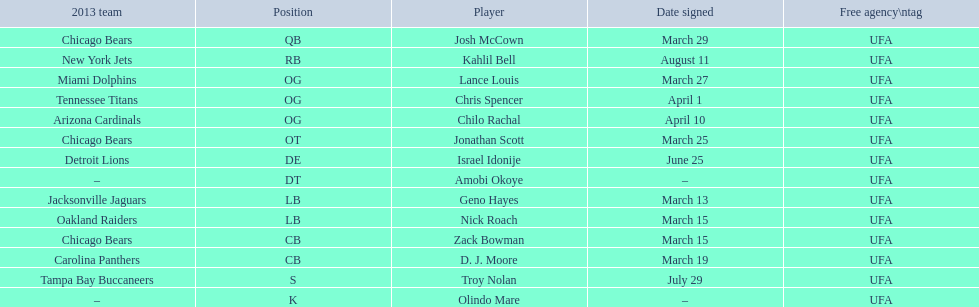Nick roach was signed the same day as what other player? Zack Bowman. 